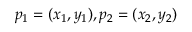Convert formula to latex. <formula><loc_0><loc_0><loc_500><loc_500>p _ { 1 } = ( x _ { 1 } , y _ { 1 } ) , p _ { 2 } = ( x _ { 2 } , y _ { 2 } )</formula> 